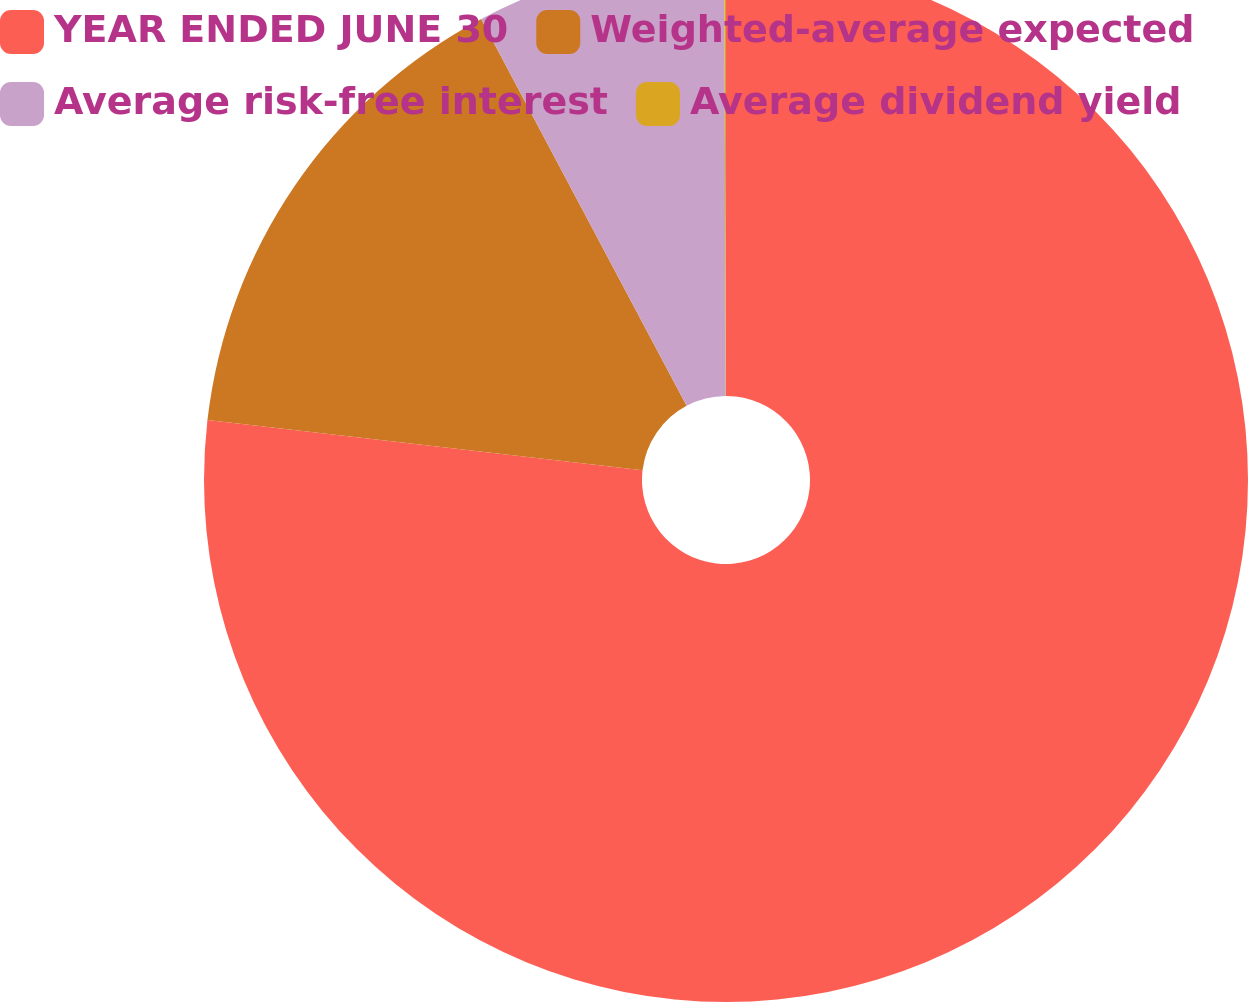Convert chart to OTSL. <chart><loc_0><loc_0><loc_500><loc_500><pie_chart><fcel>YEAR ENDED JUNE 30<fcel>Weighted-average expected<fcel>Average risk-free interest<fcel>Average dividend yield<nl><fcel>76.83%<fcel>15.4%<fcel>7.72%<fcel>0.05%<nl></chart> 